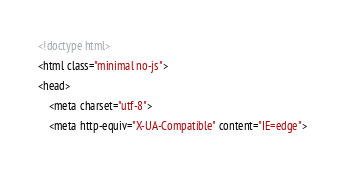<code> <loc_0><loc_0><loc_500><loc_500><_HTML_><!doctype html>
<html class="minimal no-js">
<head>
	<meta charset="utf-8">
	<meta http-equiv="X-UA-Compatible" content="IE=edge"></code> 